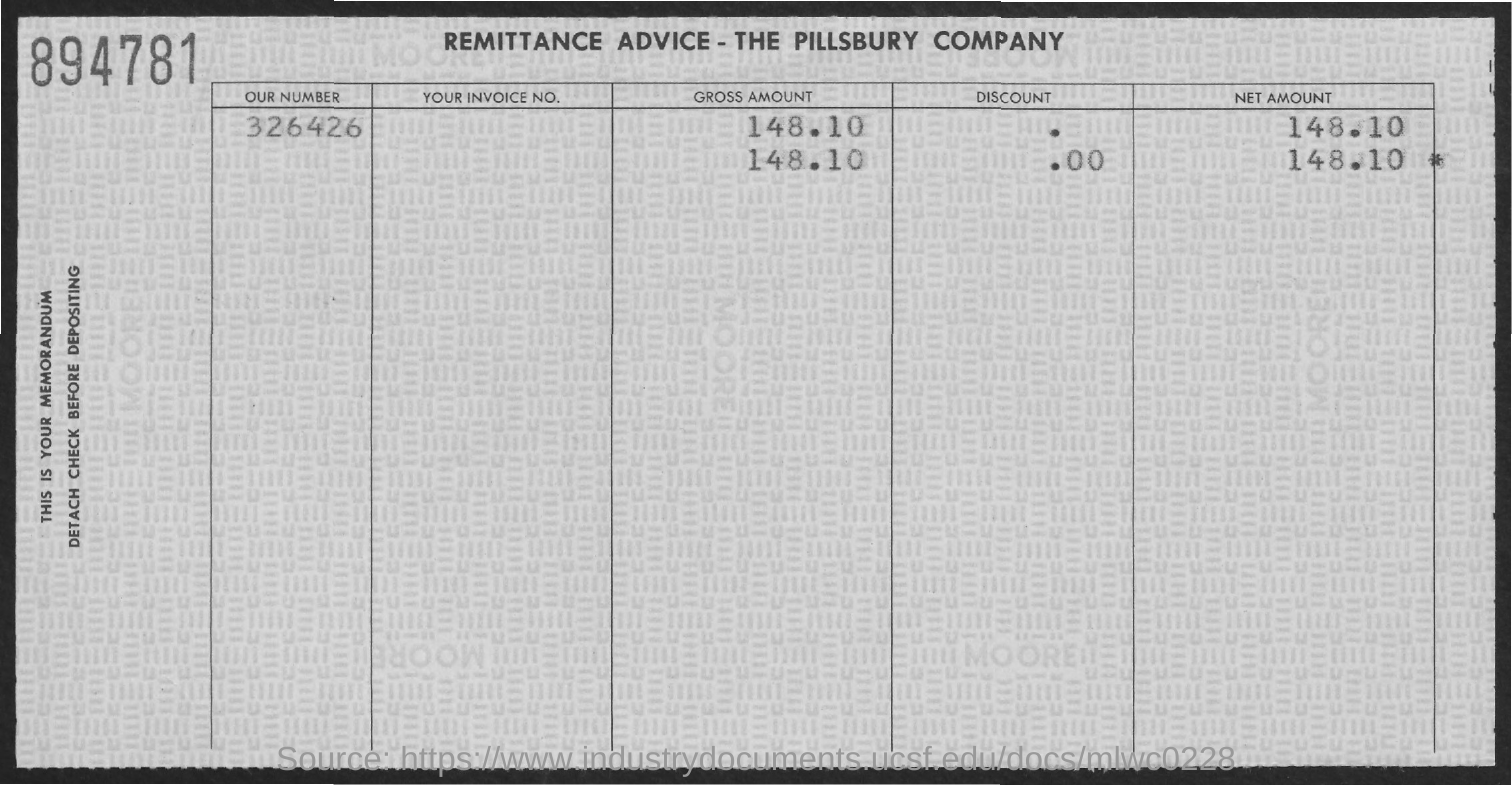What is the net amount mentioned in the remittance advice?
Your answer should be very brief. 148.10. Which company's remittance advice is given here?
Your answer should be compact. THE PILLSBURY COMPANY. 